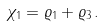Convert formula to latex. <formula><loc_0><loc_0><loc_500><loc_500>\chi _ { 1 } = \varrho _ { 1 } + \varrho _ { 3 } \, .</formula> 